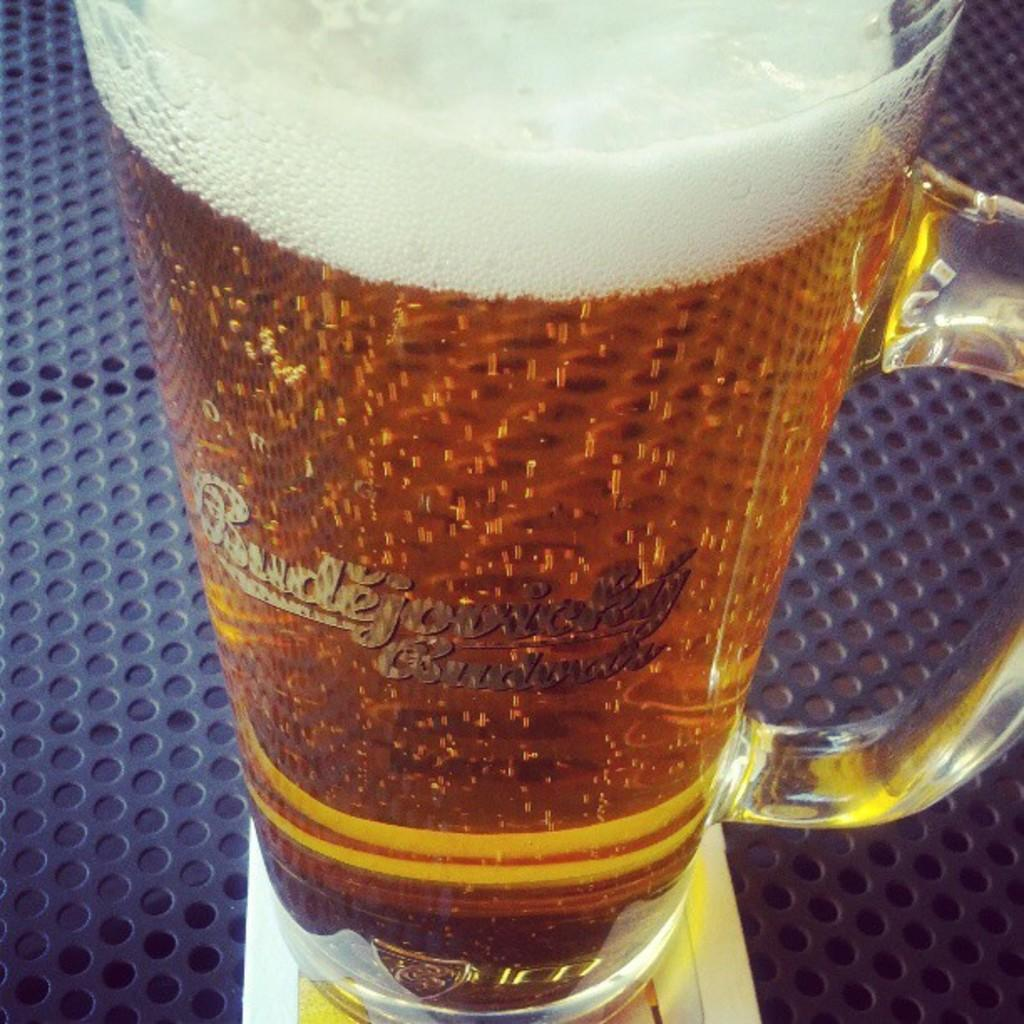<image>
Give a short and clear explanation of the subsequent image. A full mug of beer says Budejovicky on the side. 